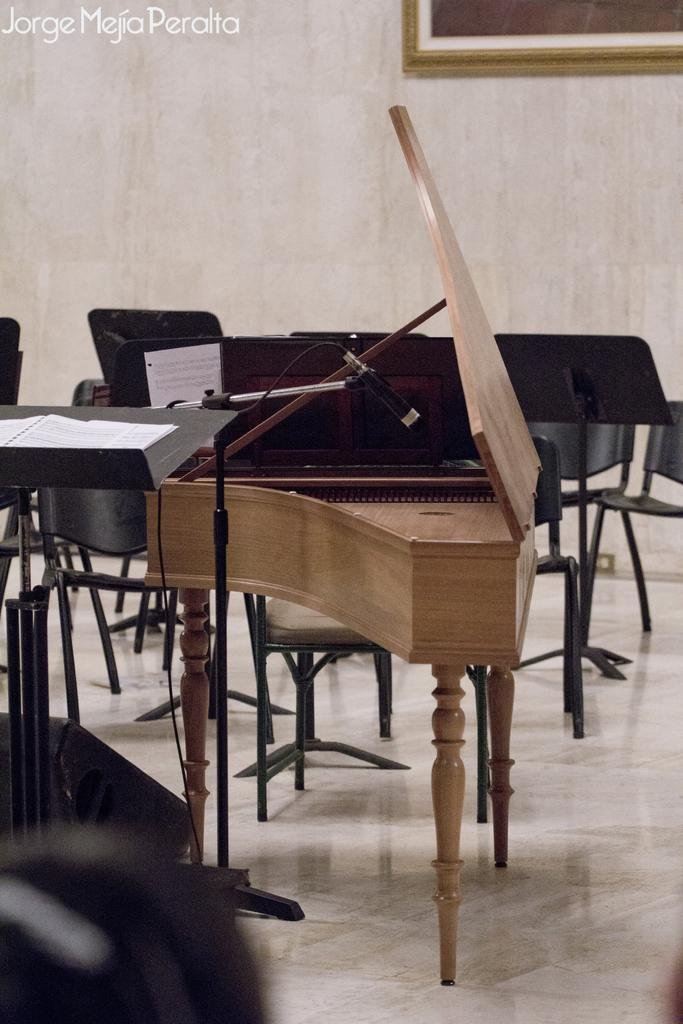What musical instrument is present in the image? There is a piano in the image. What device is used for amplifying sound in the image? There is a microphone in the image. What can be seen in the background of the image? There is a wall, empty chairs, and a photo frame in the background of the image. How does the growth of the daughter affect the cream in the image? There is no daughter or cream present in the image, so this question cannot be answered. 